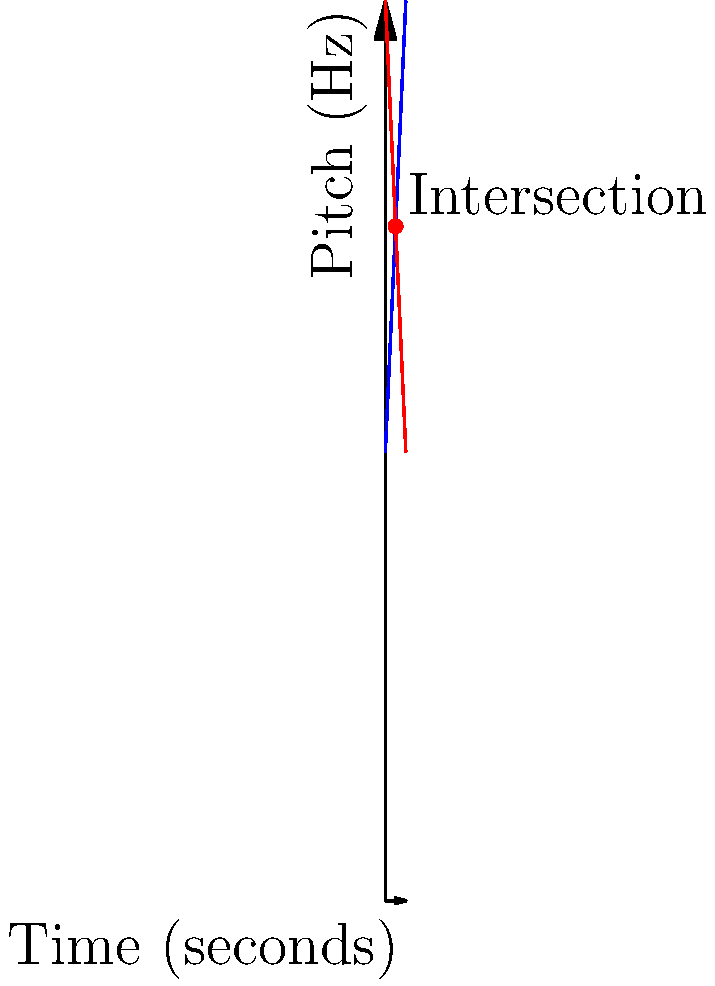In a song composition, two melodic progressions are represented by linear equations. Melody A is given by the equation $y = 220 + 22x$, and Melody B is given by $y = 440 - 22x$, where $y$ represents the pitch in Hz and $x$ represents the time in seconds. At what time do these melodies intersect, and what is the pitch at this intersection point? To find the intersection point of these two melodic progressions, we need to solve the system of equations:

1) $y = 220 + 22x$ (Melody A)
2) $y = 440 - 22x$ (Melody B)

At the intersection point, the $y$ values (pitches) will be equal. So we can set the right sides of these equations equal to each other:

3) $220 + 22x = 440 - 22x$

Now, let's solve for $x$:

4) $220 + 22x = 440 - 22x$
5) $220 + 22x + 22x = 440$
6) $220 + 44x = 440$
7) $44x = 220$
8) $x = 5$

So the melodies intersect at $x = 5$ seconds.

To find the pitch at this intersection point, we can substitute $x = 5$ into either of the original equations. Let's use Melody A:

9) $y = 220 + 22(5)$
10) $y = 220 + 110 = 330$

Therefore, the melodies intersect at 5 seconds, at a pitch of 330 Hz.
Answer: (5, 330) 